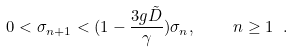<formula> <loc_0><loc_0><loc_500><loc_500>0 < \sigma _ { n + 1 } < ( 1 - \frac { 3 g \tilde { D } } { \gamma } ) \sigma _ { n } , \quad n \geq 1 \ .</formula> 